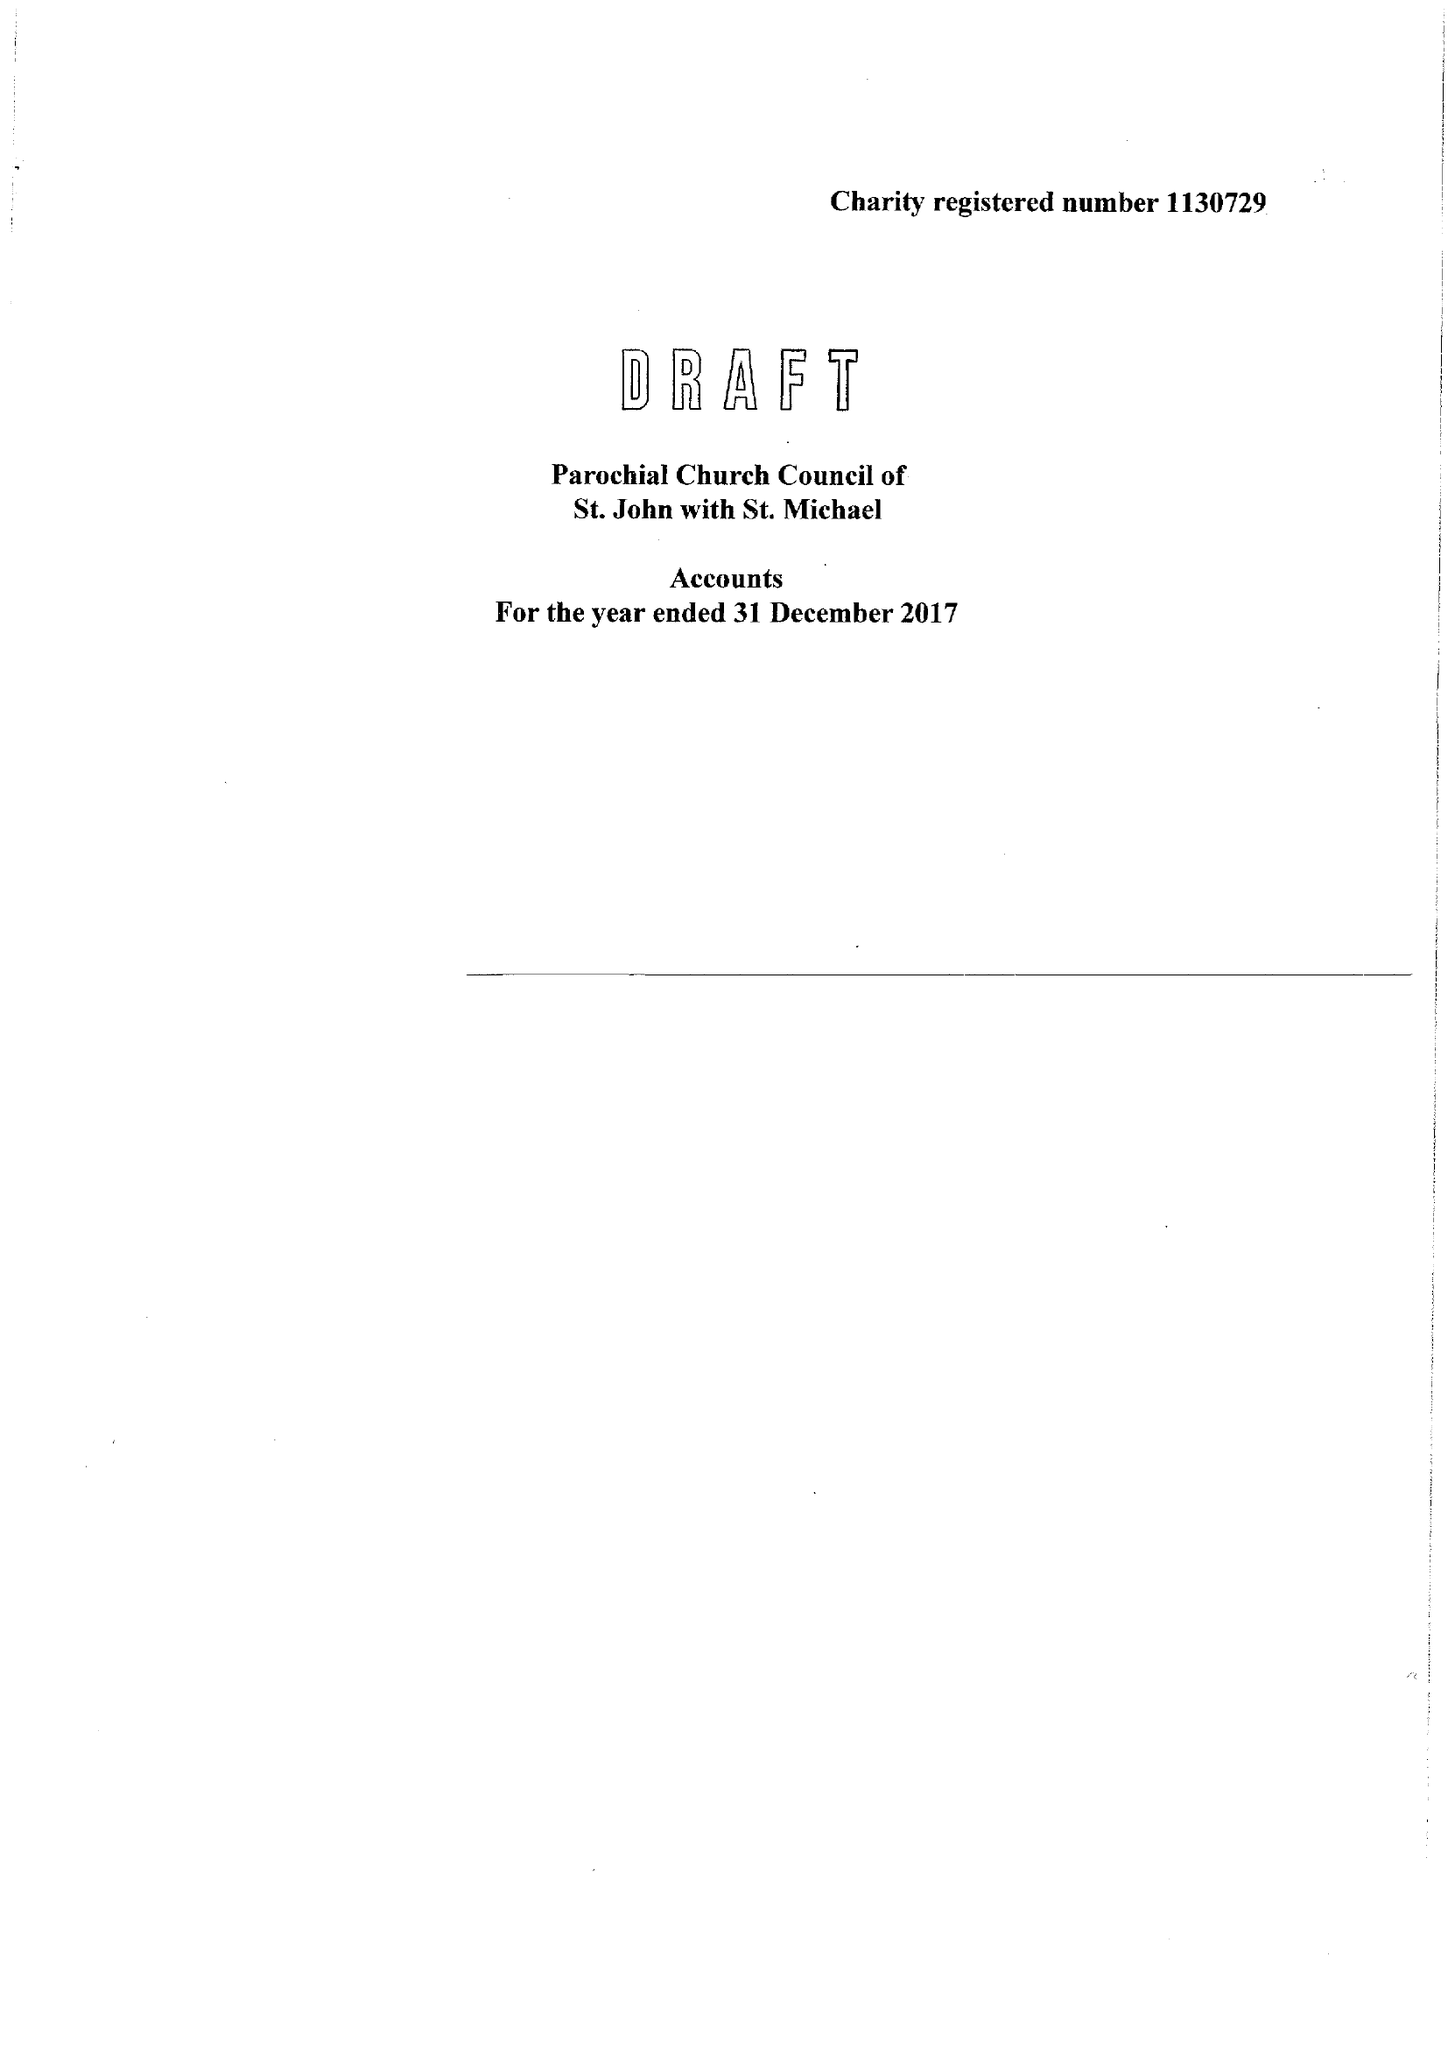What is the value for the charity_number?
Answer the question using a single word or phrase. 1130729 